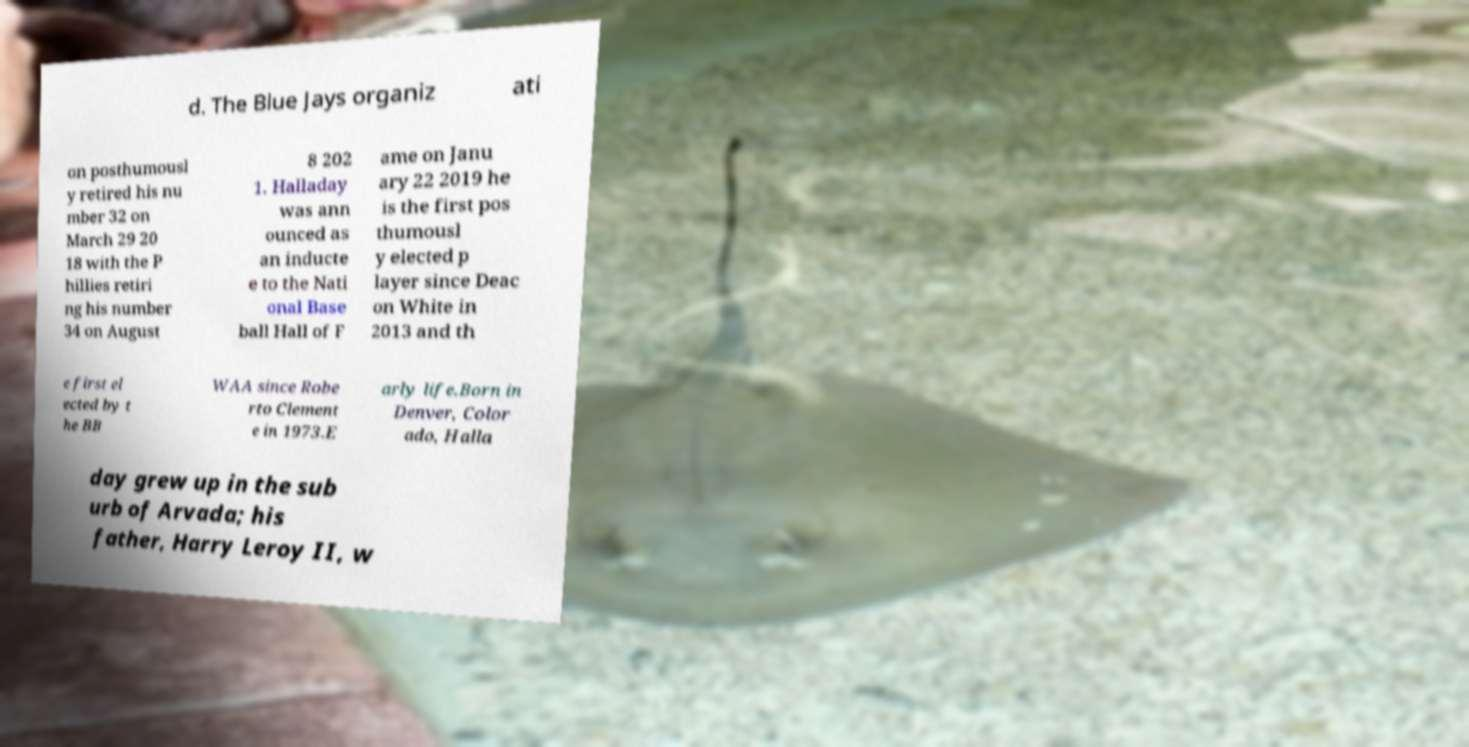There's text embedded in this image that I need extracted. Can you transcribe it verbatim? d. The Blue Jays organiz ati on posthumousl y retired his nu mber 32 on March 29 20 18 with the P hillies retiri ng his number 34 on August 8 202 1. Halladay was ann ounced as an inducte e to the Nati onal Base ball Hall of F ame on Janu ary 22 2019 he is the first pos thumousl y elected p layer since Deac on White in 2013 and th e first el ected by t he BB WAA since Robe rto Clement e in 1973.E arly life.Born in Denver, Color ado, Halla day grew up in the sub urb of Arvada; his father, Harry Leroy II, w 